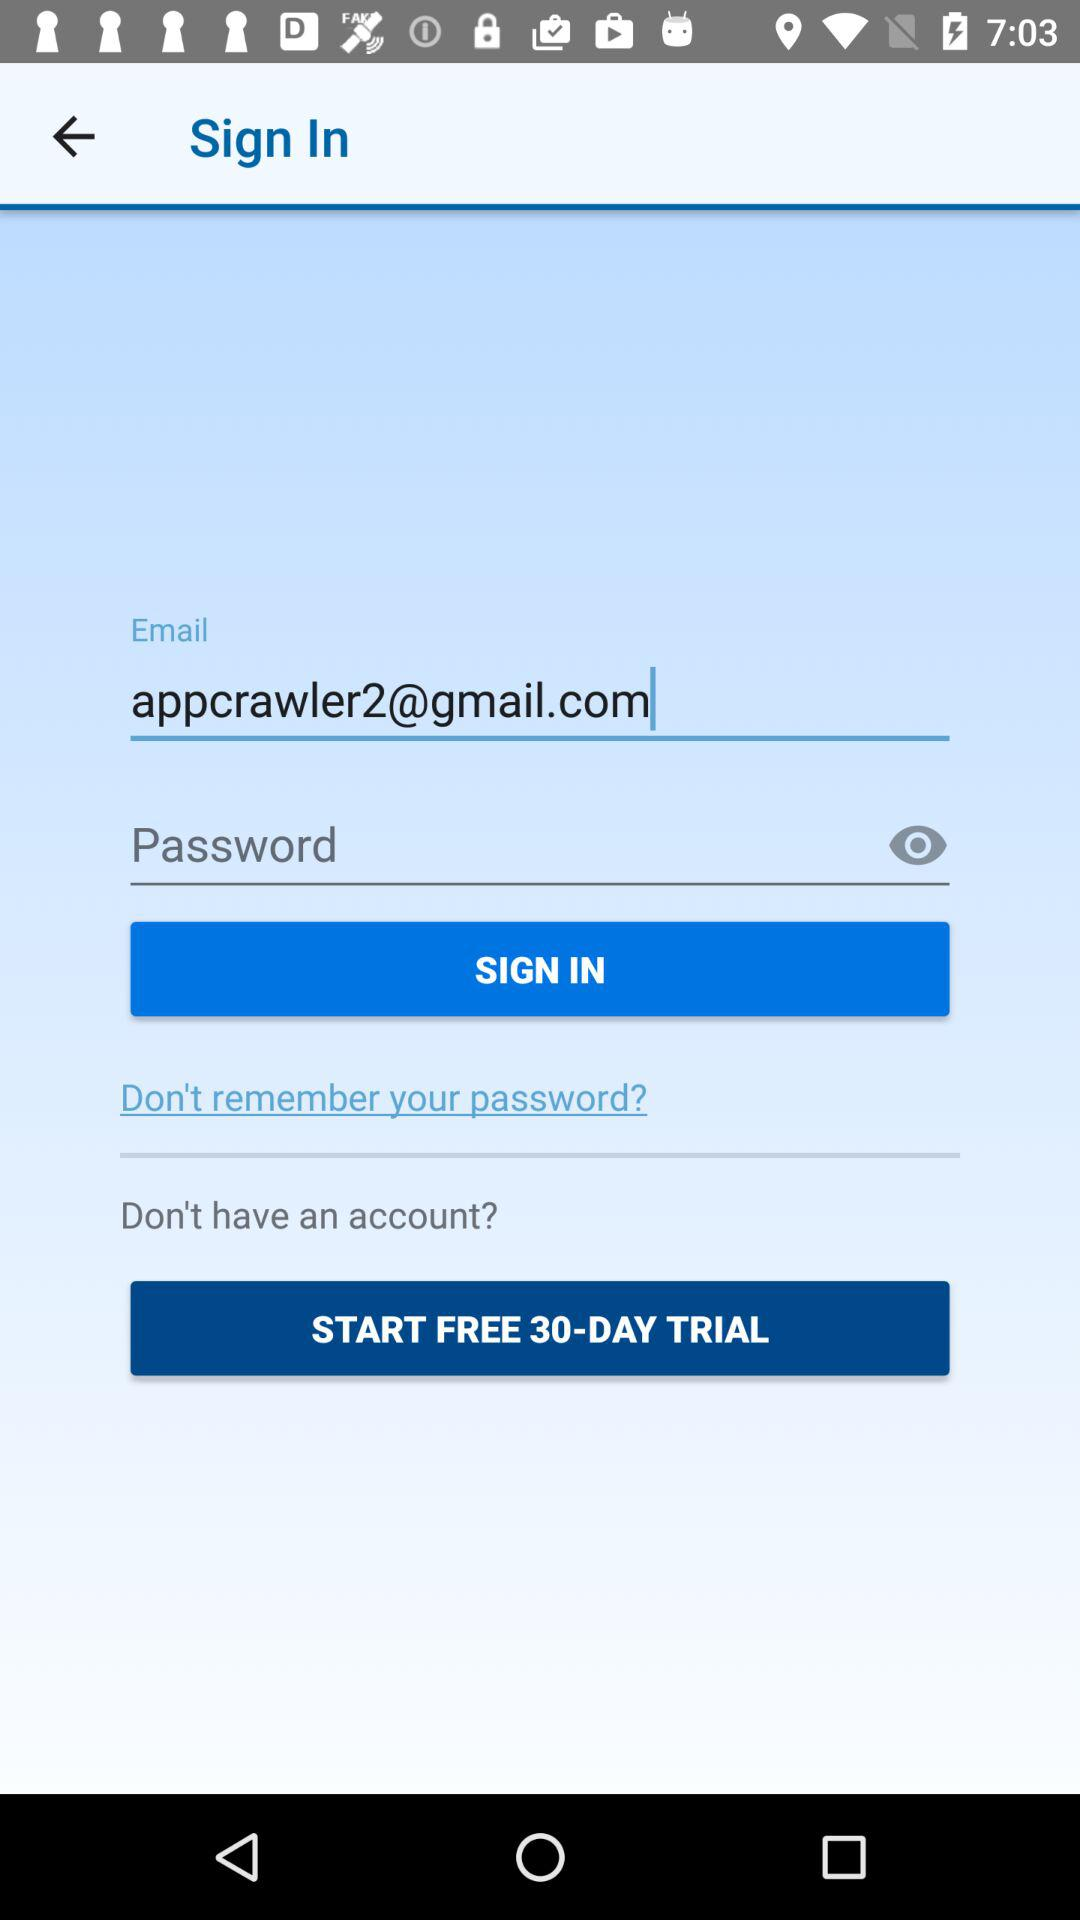How many text inputs are in the sign in form?
Answer the question using a single word or phrase. 2 